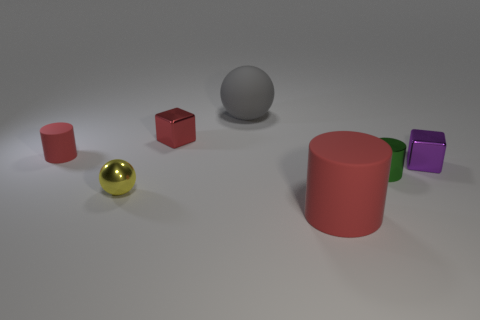Add 2 small balls. How many objects exist? 9 Subtract all balls. How many objects are left? 5 Subtract 1 green cylinders. How many objects are left? 6 Subtract all green shiny cylinders. Subtract all big cylinders. How many objects are left? 5 Add 5 tiny red cylinders. How many tiny red cylinders are left? 6 Add 5 tiny yellow rubber things. How many tiny yellow rubber things exist? 5 